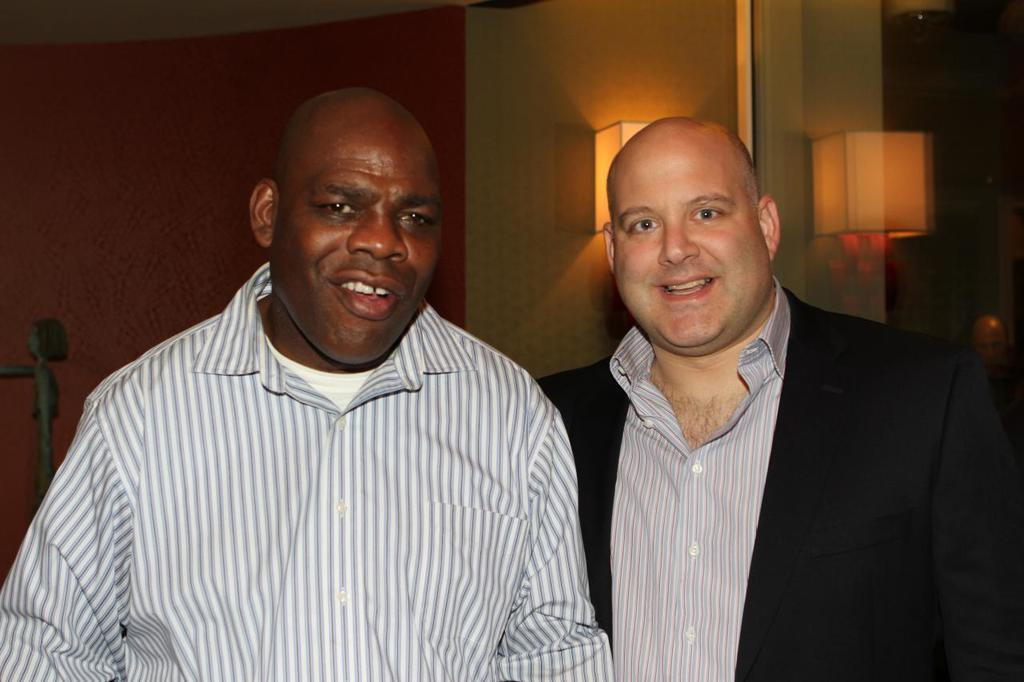How many people are present in the image? There are two people in the image. What can be observed about the clothing of the people in the image? The people are wearing different color dresses. What can be seen in the background of the image? There are lights and a wall in the background of the image. What type of fang can be seen in the image? There is no fang present in the image. Can you describe the wilderness setting in the image? There is no wilderness setting in the image; it features two people and a background with lights and a wall. 